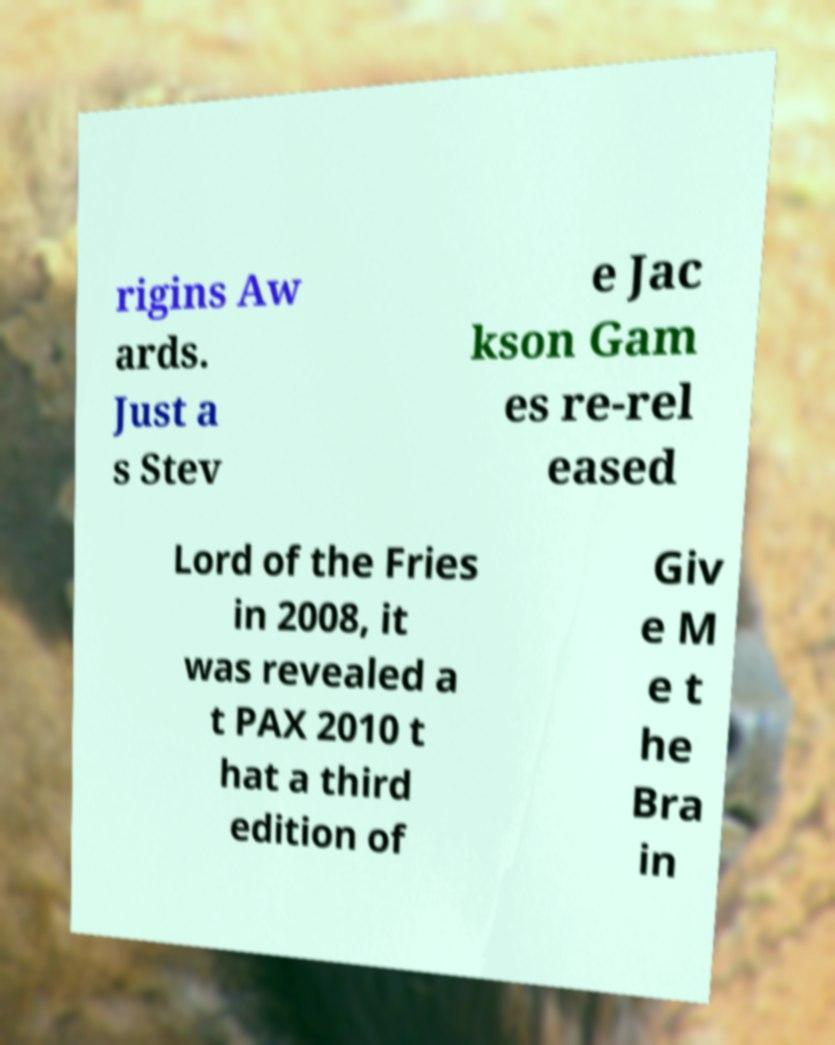There's text embedded in this image that I need extracted. Can you transcribe it verbatim? rigins Aw ards. Just a s Stev e Jac kson Gam es re-rel eased Lord of the Fries in 2008, it was revealed a t PAX 2010 t hat a third edition of Giv e M e t he Bra in 